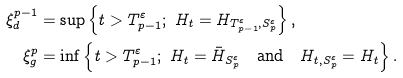Convert formula to latex. <formula><loc_0><loc_0><loc_500><loc_500>\xi _ { d } ^ { p - 1 } & = \sup \left \{ t > T _ { p - 1 } ^ { \varepsilon } ; \ H _ { t } = H _ { T _ { p - 1 } ^ { \varepsilon } , S _ { p } ^ { \varepsilon } } \right \} , \\ \xi _ { g } ^ { p } & = \inf \left \{ t > T _ { p - 1 } ^ { \varepsilon } ; \ H _ { t } = \bar { H } _ { S _ { p } ^ { \varepsilon } } \quad \text {and} \quad H _ { t , S ^ { \varepsilon } _ { p } } = H _ { t } \right \} .</formula> 